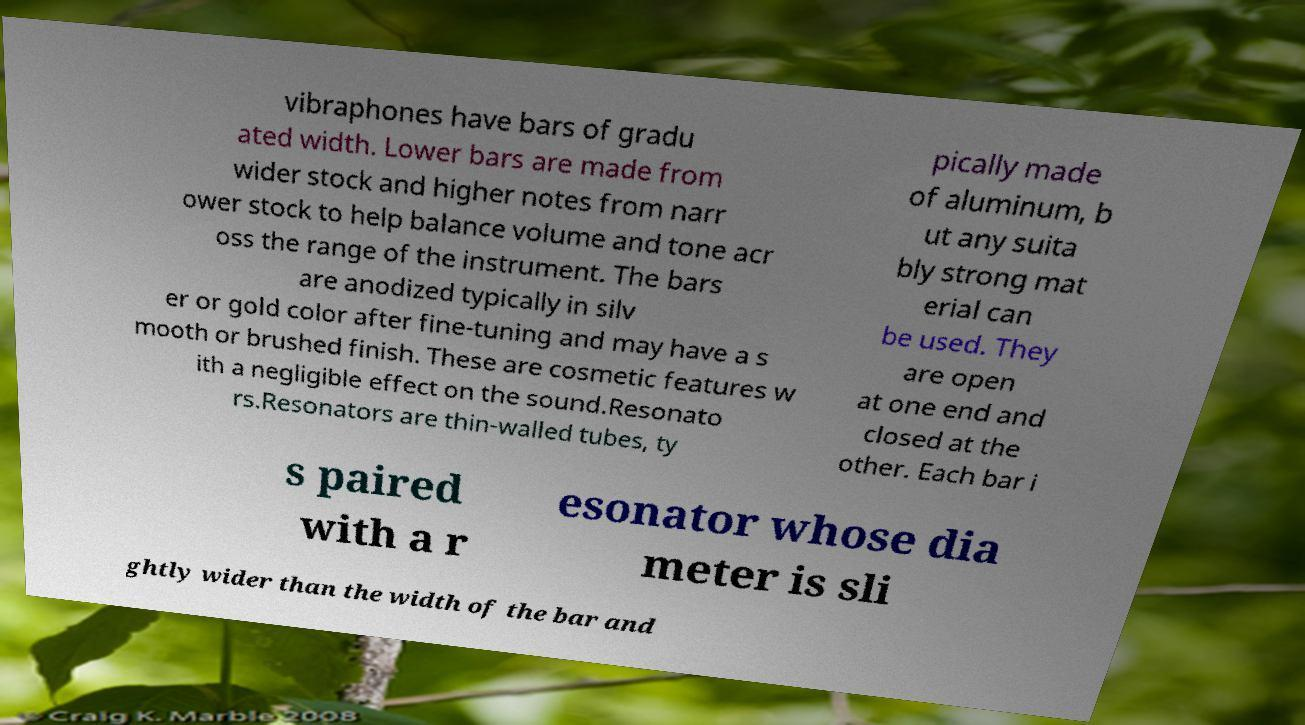Can you read and provide the text displayed in the image?This photo seems to have some interesting text. Can you extract and type it out for me? vibraphones have bars of gradu ated width. Lower bars are made from wider stock and higher notes from narr ower stock to help balance volume and tone acr oss the range of the instrument. The bars are anodized typically in silv er or gold color after fine-tuning and may have a s mooth or brushed finish. These are cosmetic features w ith a negligible effect on the sound.Resonato rs.Resonators are thin-walled tubes, ty pically made of aluminum, b ut any suita bly strong mat erial can be used. They are open at one end and closed at the other. Each bar i s paired with a r esonator whose dia meter is sli ghtly wider than the width of the bar and 